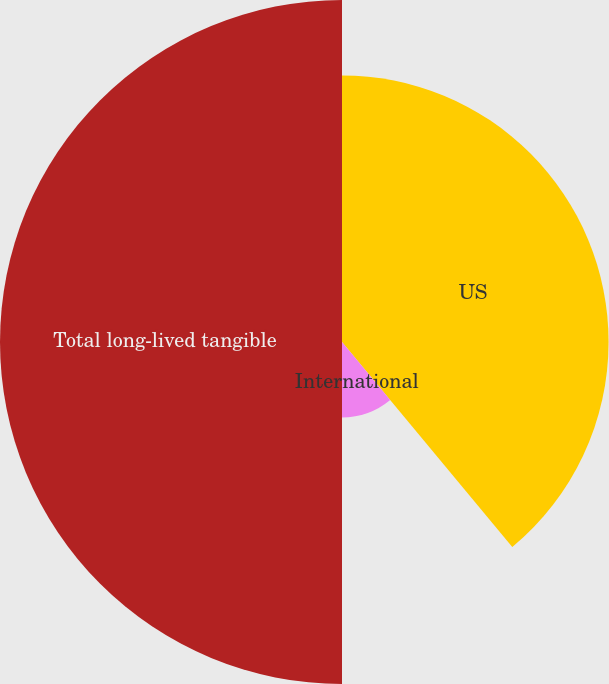<chart> <loc_0><loc_0><loc_500><loc_500><pie_chart><fcel>US<fcel>International<fcel>Total long-lived tangible<nl><fcel>38.97%<fcel>11.03%<fcel>50.0%<nl></chart> 